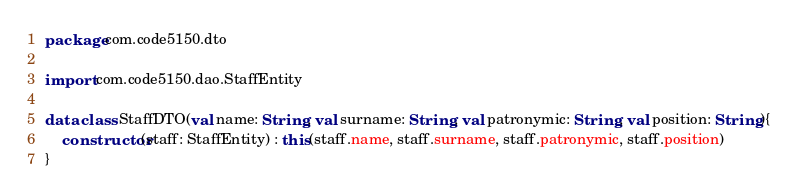<code> <loc_0><loc_0><loc_500><loc_500><_Kotlin_>package com.code5150.dto

import com.code5150.dao.StaffEntity

data class StaffDTO(val name: String, val surname: String, val patronymic: String, val position: String){
    constructor(staff: StaffEntity) : this(staff.name, staff.surname, staff.patronymic, staff.position)
}
</code> 